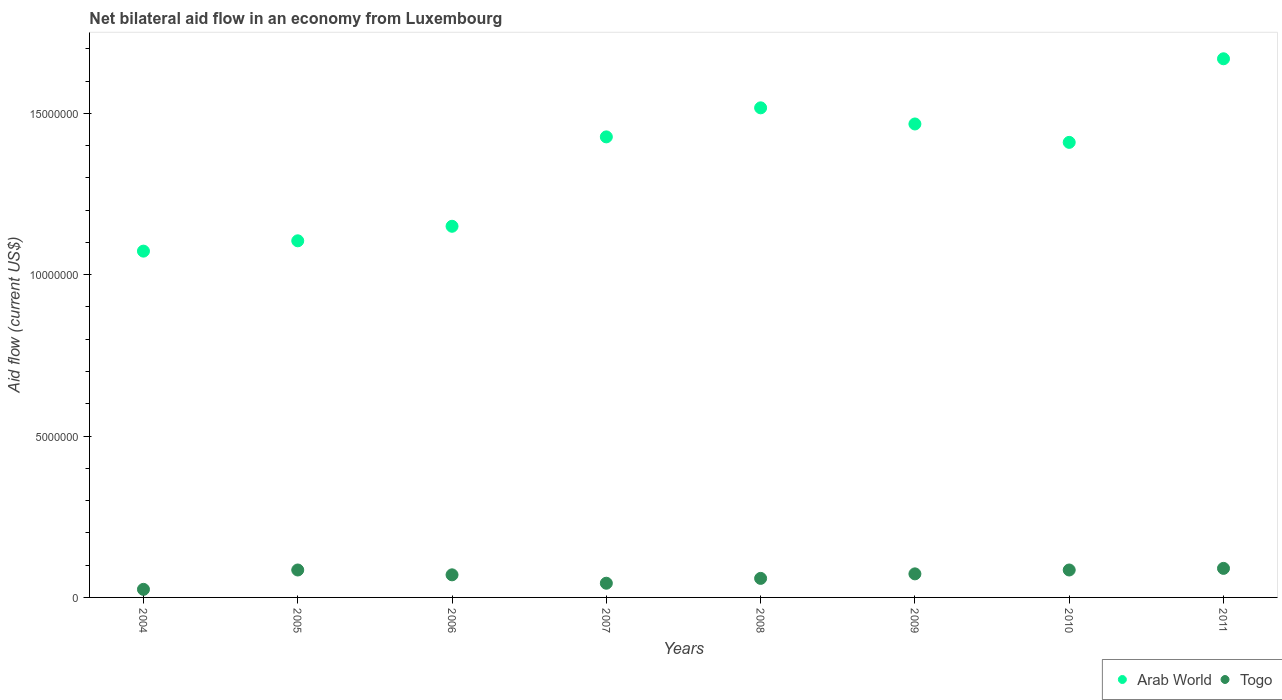How many different coloured dotlines are there?
Provide a succinct answer. 2. What is the net bilateral aid flow in Arab World in 2011?
Offer a terse response. 1.67e+07. Across all years, what is the maximum net bilateral aid flow in Arab World?
Offer a very short reply. 1.67e+07. Across all years, what is the minimum net bilateral aid flow in Arab World?
Keep it short and to the point. 1.07e+07. In which year was the net bilateral aid flow in Arab World maximum?
Make the answer very short. 2011. In which year was the net bilateral aid flow in Togo minimum?
Offer a terse response. 2004. What is the total net bilateral aid flow in Togo in the graph?
Your response must be concise. 5.31e+06. What is the difference between the net bilateral aid flow in Arab World in 2006 and that in 2008?
Ensure brevity in your answer.  -3.67e+06. What is the difference between the net bilateral aid flow in Togo in 2005 and the net bilateral aid flow in Arab World in 2009?
Provide a short and direct response. -1.38e+07. What is the average net bilateral aid flow in Arab World per year?
Your answer should be very brief. 1.35e+07. In the year 2009, what is the difference between the net bilateral aid flow in Arab World and net bilateral aid flow in Togo?
Provide a short and direct response. 1.39e+07. In how many years, is the net bilateral aid flow in Arab World greater than 11000000 US$?
Your response must be concise. 7. What is the ratio of the net bilateral aid flow in Togo in 2004 to that in 2011?
Provide a succinct answer. 0.28. Is the net bilateral aid flow in Arab World in 2008 less than that in 2009?
Give a very brief answer. No. Is the difference between the net bilateral aid flow in Arab World in 2008 and 2011 greater than the difference between the net bilateral aid flow in Togo in 2008 and 2011?
Make the answer very short. No. What is the difference between the highest and the second highest net bilateral aid flow in Togo?
Provide a succinct answer. 5.00e+04. What is the difference between the highest and the lowest net bilateral aid flow in Togo?
Keep it short and to the point. 6.50e+05. In how many years, is the net bilateral aid flow in Arab World greater than the average net bilateral aid flow in Arab World taken over all years?
Your response must be concise. 5. Is the sum of the net bilateral aid flow in Arab World in 2007 and 2009 greater than the maximum net bilateral aid flow in Togo across all years?
Keep it short and to the point. Yes. Is the net bilateral aid flow in Togo strictly greater than the net bilateral aid flow in Arab World over the years?
Provide a short and direct response. No. Is the net bilateral aid flow in Togo strictly less than the net bilateral aid flow in Arab World over the years?
Offer a terse response. Yes. Are the values on the major ticks of Y-axis written in scientific E-notation?
Provide a short and direct response. No. How many legend labels are there?
Offer a very short reply. 2. What is the title of the graph?
Offer a terse response. Net bilateral aid flow in an economy from Luxembourg. What is the label or title of the X-axis?
Your answer should be very brief. Years. What is the Aid flow (current US$) of Arab World in 2004?
Ensure brevity in your answer.  1.07e+07. What is the Aid flow (current US$) in Arab World in 2005?
Your answer should be very brief. 1.10e+07. What is the Aid flow (current US$) in Togo in 2005?
Give a very brief answer. 8.50e+05. What is the Aid flow (current US$) of Arab World in 2006?
Ensure brevity in your answer.  1.15e+07. What is the Aid flow (current US$) of Arab World in 2007?
Your answer should be compact. 1.43e+07. What is the Aid flow (current US$) of Arab World in 2008?
Give a very brief answer. 1.52e+07. What is the Aid flow (current US$) in Togo in 2008?
Offer a terse response. 5.90e+05. What is the Aid flow (current US$) of Arab World in 2009?
Your answer should be compact. 1.47e+07. What is the Aid flow (current US$) in Togo in 2009?
Give a very brief answer. 7.30e+05. What is the Aid flow (current US$) in Arab World in 2010?
Your answer should be compact. 1.41e+07. What is the Aid flow (current US$) of Togo in 2010?
Your answer should be compact. 8.50e+05. What is the Aid flow (current US$) in Arab World in 2011?
Give a very brief answer. 1.67e+07. Across all years, what is the maximum Aid flow (current US$) in Arab World?
Ensure brevity in your answer.  1.67e+07. Across all years, what is the minimum Aid flow (current US$) of Arab World?
Ensure brevity in your answer.  1.07e+07. Across all years, what is the minimum Aid flow (current US$) of Togo?
Your answer should be very brief. 2.50e+05. What is the total Aid flow (current US$) of Arab World in the graph?
Provide a succinct answer. 1.08e+08. What is the total Aid flow (current US$) of Togo in the graph?
Your answer should be compact. 5.31e+06. What is the difference between the Aid flow (current US$) of Arab World in 2004 and that in 2005?
Provide a short and direct response. -3.20e+05. What is the difference between the Aid flow (current US$) of Togo in 2004 and that in 2005?
Provide a succinct answer. -6.00e+05. What is the difference between the Aid flow (current US$) in Arab World in 2004 and that in 2006?
Offer a very short reply. -7.70e+05. What is the difference between the Aid flow (current US$) in Togo in 2004 and that in 2006?
Provide a succinct answer. -4.50e+05. What is the difference between the Aid flow (current US$) in Arab World in 2004 and that in 2007?
Your answer should be very brief. -3.54e+06. What is the difference between the Aid flow (current US$) in Arab World in 2004 and that in 2008?
Keep it short and to the point. -4.44e+06. What is the difference between the Aid flow (current US$) of Arab World in 2004 and that in 2009?
Your answer should be compact. -3.94e+06. What is the difference between the Aid flow (current US$) of Togo in 2004 and that in 2009?
Ensure brevity in your answer.  -4.80e+05. What is the difference between the Aid flow (current US$) in Arab World in 2004 and that in 2010?
Provide a succinct answer. -3.37e+06. What is the difference between the Aid flow (current US$) of Togo in 2004 and that in 2010?
Give a very brief answer. -6.00e+05. What is the difference between the Aid flow (current US$) of Arab World in 2004 and that in 2011?
Offer a terse response. -5.96e+06. What is the difference between the Aid flow (current US$) of Togo in 2004 and that in 2011?
Your answer should be compact. -6.50e+05. What is the difference between the Aid flow (current US$) in Arab World in 2005 and that in 2006?
Ensure brevity in your answer.  -4.50e+05. What is the difference between the Aid flow (current US$) of Togo in 2005 and that in 2006?
Your answer should be very brief. 1.50e+05. What is the difference between the Aid flow (current US$) in Arab World in 2005 and that in 2007?
Offer a terse response. -3.22e+06. What is the difference between the Aid flow (current US$) in Togo in 2005 and that in 2007?
Provide a short and direct response. 4.10e+05. What is the difference between the Aid flow (current US$) of Arab World in 2005 and that in 2008?
Make the answer very short. -4.12e+06. What is the difference between the Aid flow (current US$) of Arab World in 2005 and that in 2009?
Provide a short and direct response. -3.62e+06. What is the difference between the Aid flow (current US$) of Arab World in 2005 and that in 2010?
Give a very brief answer. -3.05e+06. What is the difference between the Aid flow (current US$) in Togo in 2005 and that in 2010?
Your answer should be very brief. 0. What is the difference between the Aid flow (current US$) of Arab World in 2005 and that in 2011?
Ensure brevity in your answer.  -5.64e+06. What is the difference between the Aid flow (current US$) in Togo in 2005 and that in 2011?
Your answer should be very brief. -5.00e+04. What is the difference between the Aid flow (current US$) of Arab World in 2006 and that in 2007?
Offer a terse response. -2.77e+06. What is the difference between the Aid flow (current US$) of Togo in 2006 and that in 2007?
Provide a succinct answer. 2.60e+05. What is the difference between the Aid flow (current US$) of Arab World in 2006 and that in 2008?
Make the answer very short. -3.67e+06. What is the difference between the Aid flow (current US$) in Arab World in 2006 and that in 2009?
Give a very brief answer. -3.17e+06. What is the difference between the Aid flow (current US$) in Arab World in 2006 and that in 2010?
Your answer should be compact. -2.60e+06. What is the difference between the Aid flow (current US$) in Arab World in 2006 and that in 2011?
Provide a short and direct response. -5.19e+06. What is the difference between the Aid flow (current US$) in Arab World in 2007 and that in 2008?
Your answer should be very brief. -9.00e+05. What is the difference between the Aid flow (current US$) in Arab World in 2007 and that in 2009?
Your answer should be compact. -4.00e+05. What is the difference between the Aid flow (current US$) of Togo in 2007 and that in 2010?
Provide a short and direct response. -4.10e+05. What is the difference between the Aid flow (current US$) in Arab World in 2007 and that in 2011?
Your response must be concise. -2.42e+06. What is the difference between the Aid flow (current US$) of Togo in 2007 and that in 2011?
Provide a short and direct response. -4.60e+05. What is the difference between the Aid flow (current US$) in Arab World in 2008 and that in 2009?
Your response must be concise. 5.00e+05. What is the difference between the Aid flow (current US$) in Arab World in 2008 and that in 2010?
Provide a succinct answer. 1.07e+06. What is the difference between the Aid flow (current US$) of Togo in 2008 and that in 2010?
Your response must be concise. -2.60e+05. What is the difference between the Aid flow (current US$) in Arab World in 2008 and that in 2011?
Your answer should be compact. -1.52e+06. What is the difference between the Aid flow (current US$) in Togo in 2008 and that in 2011?
Your answer should be compact. -3.10e+05. What is the difference between the Aid flow (current US$) in Arab World in 2009 and that in 2010?
Your response must be concise. 5.70e+05. What is the difference between the Aid flow (current US$) of Togo in 2009 and that in 2010?
Offer a very short reply. -1.20e+05. What is the difference between the Aid flow (current US$) in Arab World in 2009 and that in 2011?
Keep it short and to the point. -2.02e+06. What is the difference between the Aid flow (current US$) of Togo in 2009 and that in 2011?
Provide a succinct answer. -1.70e+05. What is the difference between the Aid flow (current US$) in Arab World in 2010 and that in 2011?
Give a very brief answer. -2.59e+06. What is the difference between the Aid flow (current US$) in Arab World in 2004 and the Aid flow (current US$) in Togo in 2005?
Offer a terse response. 9.88e+06. What is the difference between the Aid flow (current US$) of Arab World in 2004 and the Aid flow (current US$) of Togo in 2006?
Provide a succinct answer. 1.00e+07. What is the difference between the Aid flow (current US$) of Arab World in 2004 and the Aid flow (current US$) of Togo in 2007?
Give a very brief answer. 1.03e+07. What is the difference between the Aid flow (current US$) in Arab World in 2004 and the Aid flow (current US$) in Togo in 2008?
Keep it short and to the point. 1.01e+07. What is the difference between the Aid flow (current US$) in Arab World in 2004 and the Aid flow (current US$) in Togo in 2010?
Keep it short and to the point. 9.88e+06. What is the difference between the Aid flow (current US$) in Arab World in 2004 and the Aid flow (current US$) in Togo in 2011?
Provide a short and direct response. 9.83e+06. What is the difference between the Aid flow (current US$) of Arab World in 2005 and the Aid flow (current US$) of Togo in 2006?
Make the answer very short. 1.04e+07. What is the difference between the Aid flow (current US$) of Arab World in 2005 and the Aid flow (current US$) of Togo in 2007?
Your answer should be very brief. 1.06e+07. What is the difference between the Aid flow (current US$) of Arab World in 2005 and the Aid flow (current US$) of Togo in 2008?
Keep it short and to the point. 1.05e+07. What is the difference between the Aid flow (current US$) of Arab World in 2005 and the Aid flow (current US$) of Togo in 2009?
Provide a succinct answer. 1.03e+07. What is the difference between the Aid flow (current US$) of Arab World in 2005 and the Aid flow (current US$) of Togo in 2010?
Ensure brevity in your answer.  1.02e+07. What is the difference between the Aid flow (current US$) in Arab World in 2005 and the Aid flow (current US$) in Togo in 2011?
Make the answer very short. 1.02e+07. What is the difference between the Aid flow (current US$) of Arab World in 2006 and the Aid flow (current US$) of Togo in 2007?
Your answer should be compact. 1.11e+07. What is the difference between the Aid flow (current US$) in Arab World in 2006 and the Aid flow (current US$) in Togo in 2008?
Your answer should be compact. 1.09e+07. What is the difference between the Aid flow (current US$) of Arab World in 2006 and the Aid flow (current US$) of Togo in 2009?
Your response must be concise. 1.08e+07. What is the difference between the Aid flow (current US$) in Arab World in 2006 and the Aid flow (current US$) in Togo in 2010?
Keep it short and to the point. 1.06e+07. What is the difference between the Aid flow (current US$) of Arab World in 2006 and the Aid flow (current US$) of Togo in 2011?
Keep it short and to the point. 1.06e+07. What is the difference between the Aid flow (current US$) of Arab World in 2007 and the Aid flow (current US$) of Togo in 2008?
Give a very brief answer. 1.37e+07. What is the difference between the Aid flow (current US$) in Arab World in 2007 and the Aid flow (current US$) in Togo in 2009?
Provide a succinct answer. 1.35e+07. What is the difference between the Aid flow (current US$) in Arab World in 2007 and the Aid flow (current US$) in Togo in 2010?
Make the answer very short. 1.34e+07. What is the difference between the Aid flow (current US$) of Arab World in 2007 and the Aid flow (current US$) of Togo in 2011?
Offer a terse response. 1.34e+07. What is the difference between the Aid flow (current US$) of Arab World in 2008 and the Aid flow (current US$) of Togo in 2009?
Give a very brief answer. 1.44e+07. What is the difference between the Aid flow (current US$) of Arab World in 2008 and the Aid flow (current US$) of Togo in 2010?
Give a very brief answer. 1.43e+07. What is the difference between the Aid flow (current US$) of Arab World in 2008 and the Aid flow (current US$) of Togo in 2011?
Provide a short and direct response. 1.43e+07. What is the difference between the Aid flow (current US$) of Arab World in 2009 and the Aid flow (current US$) of Togo in 2010?
Keep it short and to the point. 1.38e+07. What is the difference between the Aid flow (current US$) of Arab World in 2009 and the Aid flow (current US$) of Togo in 2011?
Give a very brief answer. 1.38e+07. What is the difference between the Aid flow (current US$) of Arab World in 2010 and the Aid flow (current US$) of Togo in 2011?
Ensure brevity in your answer.  1.32e+07. What is the average Aid flow (current US$) in Arab World per year?
Provide a short and direct response. 1.35e+07. What is the average Aid flow (current US$) in Togo per year?
Offer a terse response. 6.64e+05. In the year 2004, what is the difference between the Aid flow (current US$) in Arab World and Aid flow (current US$) in Togo?
Your answer should be compact. 1.05e+07. In the year 2005, what is the difference between the Aid flow (current US$) of Arab World and Aid flow (current US$) of Togo?
Your answer should be very brief. 1.02e+07. In the year 2006, what is the difference between the Aid flow (current US$) of Arab World and Aid flow (current US$) of Togo?
Offer a terse response. 1.08e+07. In the year 2007, what is the difference between the Aid flow (current US$) of Arab World and Aid flow (current US$) of Togo?
Offer a very short reply. 1.38e+07. In the year 2008, what is the difference between the Aid flow (current US$) in Arab World and Aid flow (current US$) in Togo?
Your response must be concise. 1.46e+07. In the year 2009, what is the difference between the Aid flow (current US$) of Arab World and Aid flow (current US$) of Togo?
Provide a succinct answer. 1.39e+07. In the year 2010, what is the difference between the Aid flow (current US$) of Arab World and Aid flow (current US$) of Togo?
Your answer should be compact. 1.32e+07. In the year 2011, what is the difference between the Aid flow (current US$) of Arab World and Aid flow (current US$) of Togo?
Your answer should be compact. 1.58e+07. What is the ratio of the Aid flow (current US$) in Arab World in 2004 to that in 2005?
Your response must be concise. 0.97. What is the ratio of the Aid flow (current US$) in Togo in 2004 to that in 2005?
Offer a very short reply. 0.29. What is the ratio of the Aid flow (current US$) in Arab World in 2004 to that in 2006?
Keep it short and to the point. 0.93. What is the ratio of the Aid flow (current US$) of Togo in 2004 to that in 2006?
Your answer should be compact. 0.36. What is the ratio of the Aid flow (current US$) of Arab World in 2004 to that in 2007?
Your response must be concise. 0.75. What is the ratio of the Aid flow (current US$) in Togo in 2004 to that in 2007?
Give a very brief answer. 0.57. What is the ratio of the Aid flow (current US$) of Arab World in 2004 to that in 2008?
Make the answer very short. 0.71. What is the ratio of the Aid flow (current US$) of Togo in 2004 to that in 2008?
Ensure brevity in your answer.  0.42. What is the ratio of the Aid flow (current US$) in Arab World in 2004 to that in 2009?
Keep it short and to the point. 0.73. What is the ratio of the Aid flow (current US$) in Togo in 2004 to that in 2009?
Your answer should be compact. 0.34. What is the ratio of the Aid flow (current US$) in Arab World in 2004 to that in 2010?
Your response must be concise. 0.76. What is the ratio of the Aid flow (current US$) in Togo in 2004 to that in 2010?
Provide a succinct answer. 0.29. What is the ratio of the Aid flow (current US$) in Arab World in 2004 to that in 2011?
Your answer should be compact. 0.64. What is the ratio of the Aid flow (current US$) of Togo in 2004 to that in 2011?
Ensure brevity in your answer.  0.28. What is the ratio of the Aid flow (current US$) of Arab World in 2005 to that in 2006?
Keep it short and to the point. 0.96. What is the ratio of the Aid flow (current US$) in Togo in 2005 to that in 2006?
Your answer should be very brief. 1.21. What is the ratio of the Aid flow (current US$) in Arab World in 2005 to that in 2007?
Give a very brief answer. 0.77. What is the ratio of the Aid flow (current US$) of Togo in 2005 to that in 2007?
Offer a terse response. 1.93. What is the ratio of the Aid flow (current US$) in Arab World in 2005 to that in 2008?
Provide a succinct answer. 0.73. What is the ratio of the Aid flow (current US$) of Togo in 2005 to that in 2008?
Your answer should be compact. 1.44. What is the ratio of the Aid flow (current US$) in Arab World in 2005 to that in 2009?
Provide a short and direct response. 0.75. What is the ratio of the Aid flow (current US$) of Togo in 2005 to that in 2009?
Your response must be concise. 1.16. What is the ratio of the Aid flow (current US$) in Arab World in 2005 to that in 2010?
Your answer should be very brief. 0.78. What is the ratio of the Aid flow (current US$) in Arab World in 2005 to that in 2011?
Make the answer very short. 0.66. What is the ratio of the Aid flow (current US$) of Arab World in 2006 to that in 2007?
Ensure brevity in your answer.  0.81. What is the ratio of the Aid flow (current US$) of Togo in 2006 to that in 2007?
Offer a terse response. 1.59. What is the ratio of the Aid flow (current US$) of Arab World in 2006 to that in 2008?
Ensure brevity in your answer.  0.76. What is the ratio of the Aid flow (current US$) of Togo in 2006 to that in 2008?
Ensure brevity in your answer.  1.19. What is the ratio of the Aid flow (current US$) in Arab World in 2006 to that in 2009?
Offer a very short reply. 0.78. What is the ratio of the Aid flow (current US$) of Togo in 2006 to that in 2009?
Provide a short and direct response. 0.96. What is the ratio of the Aid flow (current US$) of Arab World in 2006 to that in 2010?
Provide a succinct answer. 0.82. What is the ratio of the Aid flow (current US$) of Togo in 2006 to that in 2010?
Give a very brief answer. 0.82. What is the ratio of the Aid flow (current US$) in Arab World in 2006 to that in 2011?
Ensure brevity in your answer.  0.69. What is the ratio of the Aid flow (current US$) in Arab World in 2007 to that in 2008?
Your answer should be very brief. 0.94. What is the ratio of the Aid flow (current US$) in Togo in 2007 to that in 2008?
Your answer should be very brief. 0.75. What is the ratio of the Aid flow (current US$) of Arab World in 2007 to that in 2009?
Provide a succinct answer. 0.97. What is the ratio of the Aid flow (current US$) in Togo in 2007 to that in 2009?
Your answer should be compact. 0.6. What is the ratio of the Aid flow (current US$) in Arab World in 2007 to that in 2010?
Provide a short and direct response. 1.01. What is the ratio of the Aid flow (current US$) in Togo in 2007 to that in 2010?
Your answer should be compact. 0.52. What is the ratio of the Aid flow (current US$) of Arab World in 2007 to that in 2011?
Provide a short and direct response. 0.85. What is the ratio of the Aid flow (current US$) in Togo in 2007 to that in 2011?
Your answer should be very brief. 0.49. What is the ratio of the Aid flow (current US$) of Arab World in 2008 to that in 2009?
Provide a short and direct response. 1.03. What is the ratio of the Aid flow (current US$) in Togo in 2008 to that in 2009?
Give a very brief answer. 0.81. What is the ratio of the Aid flow (current US$) in Arab World in 2008 to that in 2010?
Provide a short and direct response. 1.08. What is the ratio of the Aid flow (current US$) in Togo in 2008 to that in 2010?
Your answer should be very brief. 0.69. What is the ratio of the Aid flow (current US$) in Arab World in 2008 to that in 2011?
Keep it short and to the point. 0.91. What is the ratio of the Aid flow (current US$) in Togo in 2008 to that in 2011?
Offer a terse response. 0.66. What is the ratio of the Aid flow (current US$) in Arab World in 2009 to that in 2010?
Make the answer very short. 1.04. What is the ratio of the Aid flow (current US$) in Togo in 2009 to that in 2010?
Offer a terse response. 0.86. What is the ratio of the Aid flow (current US$) in Arab World in 2009 to that in 2011?
Your answer should be compact. 0.88. What is the ratio of the Aid flow (current US$) in Togo in 2009 to that in 2011?
Provide a short and direct response. 0.81. What is the ratio of the Aid flow (current US$) in Arab World in 2010 to that in 2011?
Give a very brief answer. 0.84. What is the difference between the highest and the second highest Aid flow (current US$) in Arab World?
Offer a very short reply. 1.52e+06. What is the difference between the highest and the lowest Aid flow (current US$) in Arab World?
Your response must be concise. 5.96e+06. What is the difference between the highest and the lowest Aid flow (current US$) in Togo?
Your response must be concise. 6.50e+05. 